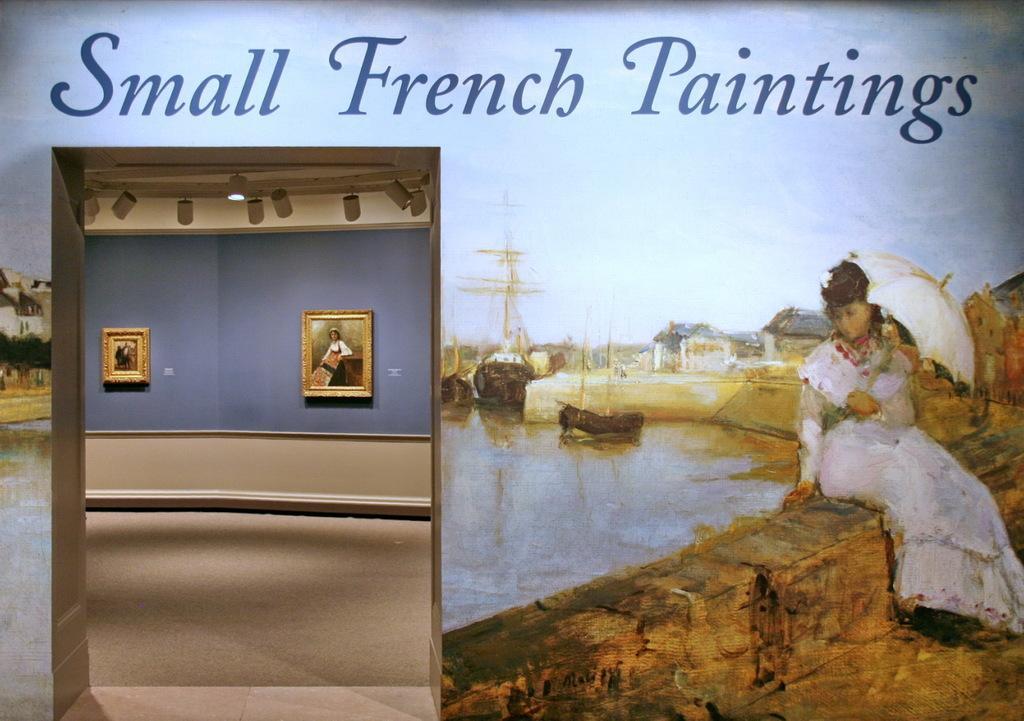Can you describe this image briefly? In this image, we can see a poster, on that poster, we can see a woman sitting and she is holding an umbrella, we can see water and there is some text on the poster. 